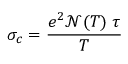Convert formula to latex. <formula><loc_0><loc_0><loc_500><loc_500>\sigma _ { c } = \frac { e ^ { 2 } \mathcal { N } ( T ) \, \tau } { T }</formula> 